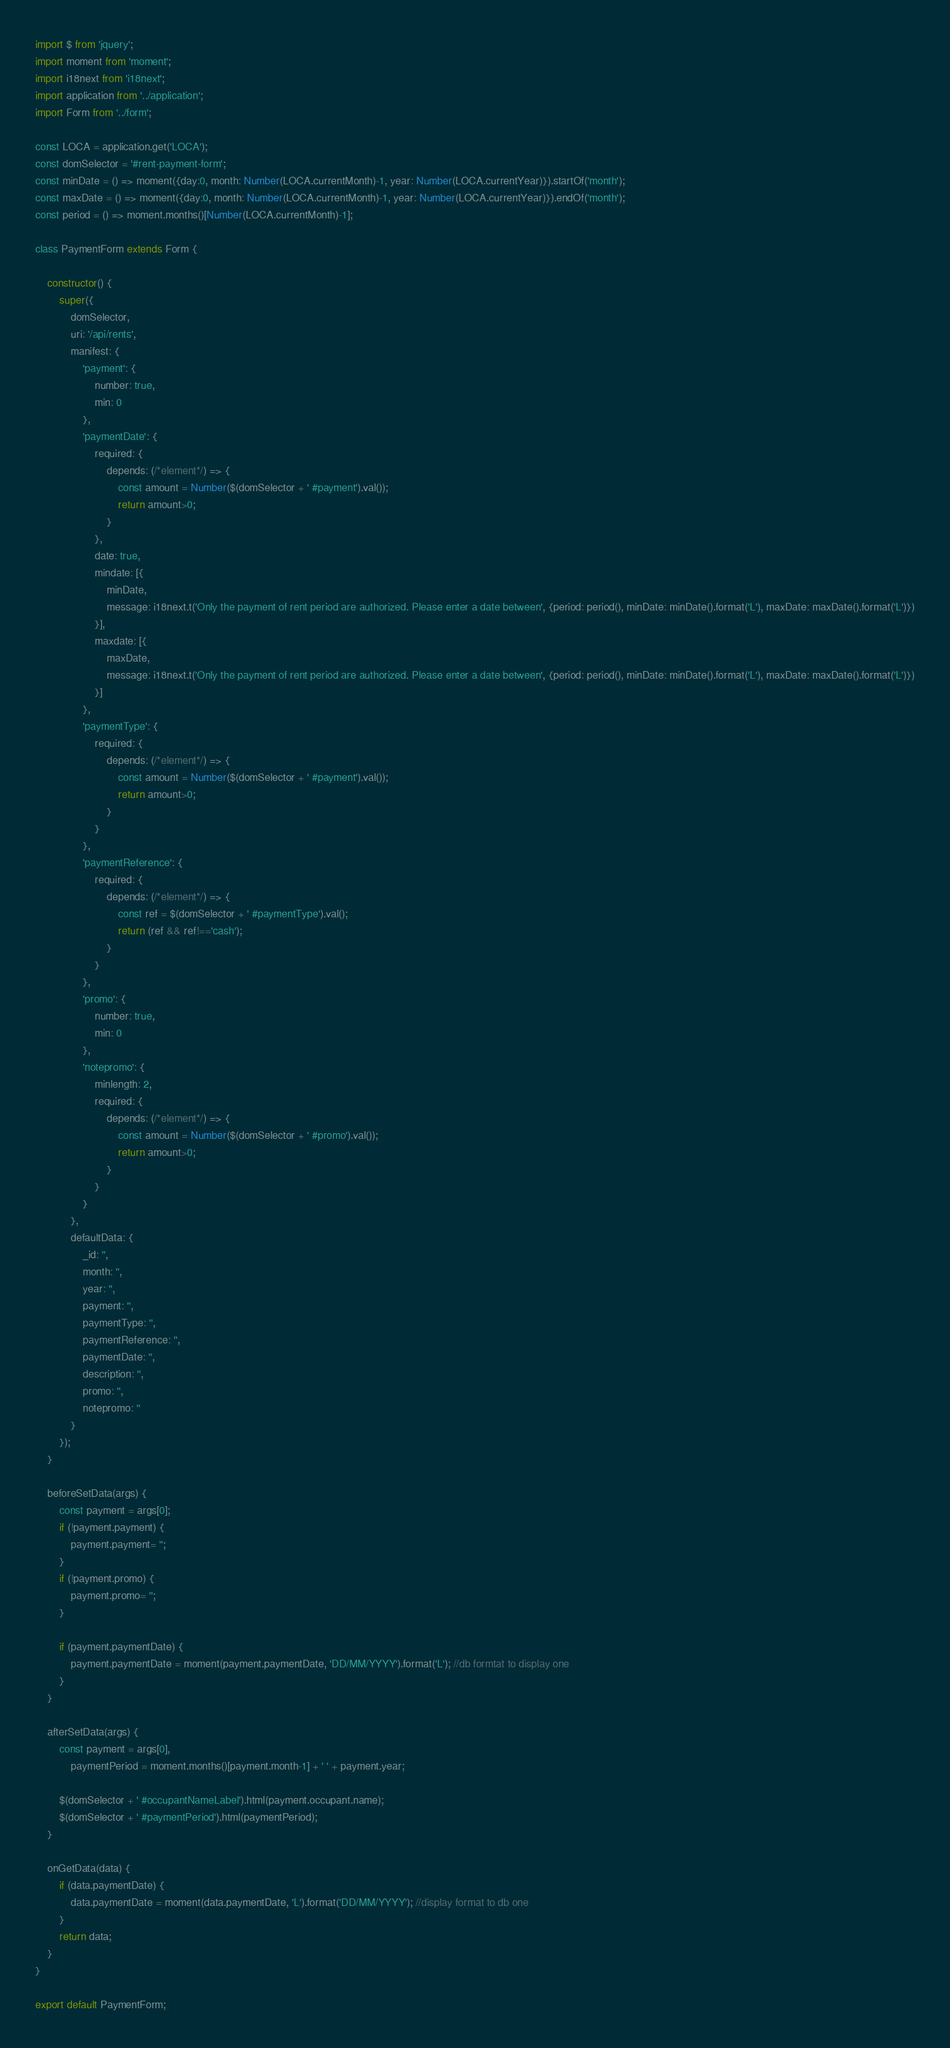<code> <loc_0><loc_0><loc_500><loc_500><_JavaScript_>import $ from 'jquery';
import moment from 'moment';
import i18next from 'i18next';
import application from '../application';
import Form from '../form';

const LOCA = application.get('LOCA');
const domSelector = '#rent-payment-form';
const minDate = () => moment({day:0, month: Number(LOCA.currentMonth)-1, year: Number(LOCA.currentYear)}).startOf('month');
const maxDate = () => moment({day:0, month: Number(LOCA.currentMonth)-1, year: Number(LOCA.currentYear)}).endOf('month');
const period = () => moment.months()[Number(LOCA.currentMonth)-1];

class PaymentForm extends Form {

    constructor() {
        super({
            domSelector,
            uri: '/api/rents',
            manifest: {
                'payment': {
                    number: true,
                    min: 0
                },
                'paymentDate': {
                    required: {
                        depends: (/*element*/) => {
                            const amount = Number($(domSelector + ' #payment').val());
                            return amount>0;
                        }
                    },
                    date: true,
                    mindate: [{
                        minDate,
                        message: i18next.t('Only the payment of rent period are authorized. Please enter a date between', {period: period(), minDate: minDate().format('L'), maxDate: maxDate().format('L')})
                    }],
                    maxdate: [{
                        maxDate,
                        message: i18next.t('Only the payment of rent period are authorized. Please enter a date between', {period: period(), minDate: minDate().format('L'), maxDate: maxDate().format('L')})
                    }]
                },
                'paymentType': {
                    required: {
                        depends: (/*element*/) => {
                            const amount = Number($(domSelector + ' #payment').val());
                            return amount>0;
                        }
                    }
                },
                'paymentReference': {
                    required: {
                        depends: (/*element*/) => {
                            const ref = $(domSelector + ' #paymentType').val();
                            return (ref && ref!=='cash');
                        }
                    }
                },
                'promo': {
                    number: true,
                    min: 0
                },
                'notepromo': {
                    minlength: 2,
                    required: {
                        depends: (/*element*/) => {
                            const amount = Number($(domSelector + ' #promo').val());
                            return amount>0;
                        }
                    }
                }
            },
            defaultData: {
                _id: '',
                month: '',
                year: '',
                payment: '',
                paymentType: '',
                paymentReference: '',
                paymentDate: '',
                description: '',
                promo: '',
                notepromo: ''
            }
        });
    }

    beforeSetData(args) {
        const payment = args[0];
        if (!payment.payment) {
            payment.payment= '';
        }
        if (!payment.promo) {
            payment.promo= '';
        }

        if (payment.paymentDate) {
            payment.paymentDate = moment(payment.paymentDate, 'DD/MM/YYYY').format('L'); //db formtat to display one
        }
    }

    afterSetData(args) {
        const payment = args[0],
            paymentPeriod = moment.months()[payment.month-1] + ' ' + payment.year;

        $(domSelector + ' #occupantNameLabel').html(payment.occupant.name);
        $(domSelector + ' #paymentPeriod').html(paymentPeriod);
    }

    onGetData(data) {
        if (data.paymentDate) {
            data.paymentDate = moment(data.paymentDate, 'L').format('DD/MM/YYYY'); //display format to db one
        }
        return data;
    }
}

export default PaymentForm;
</code> 